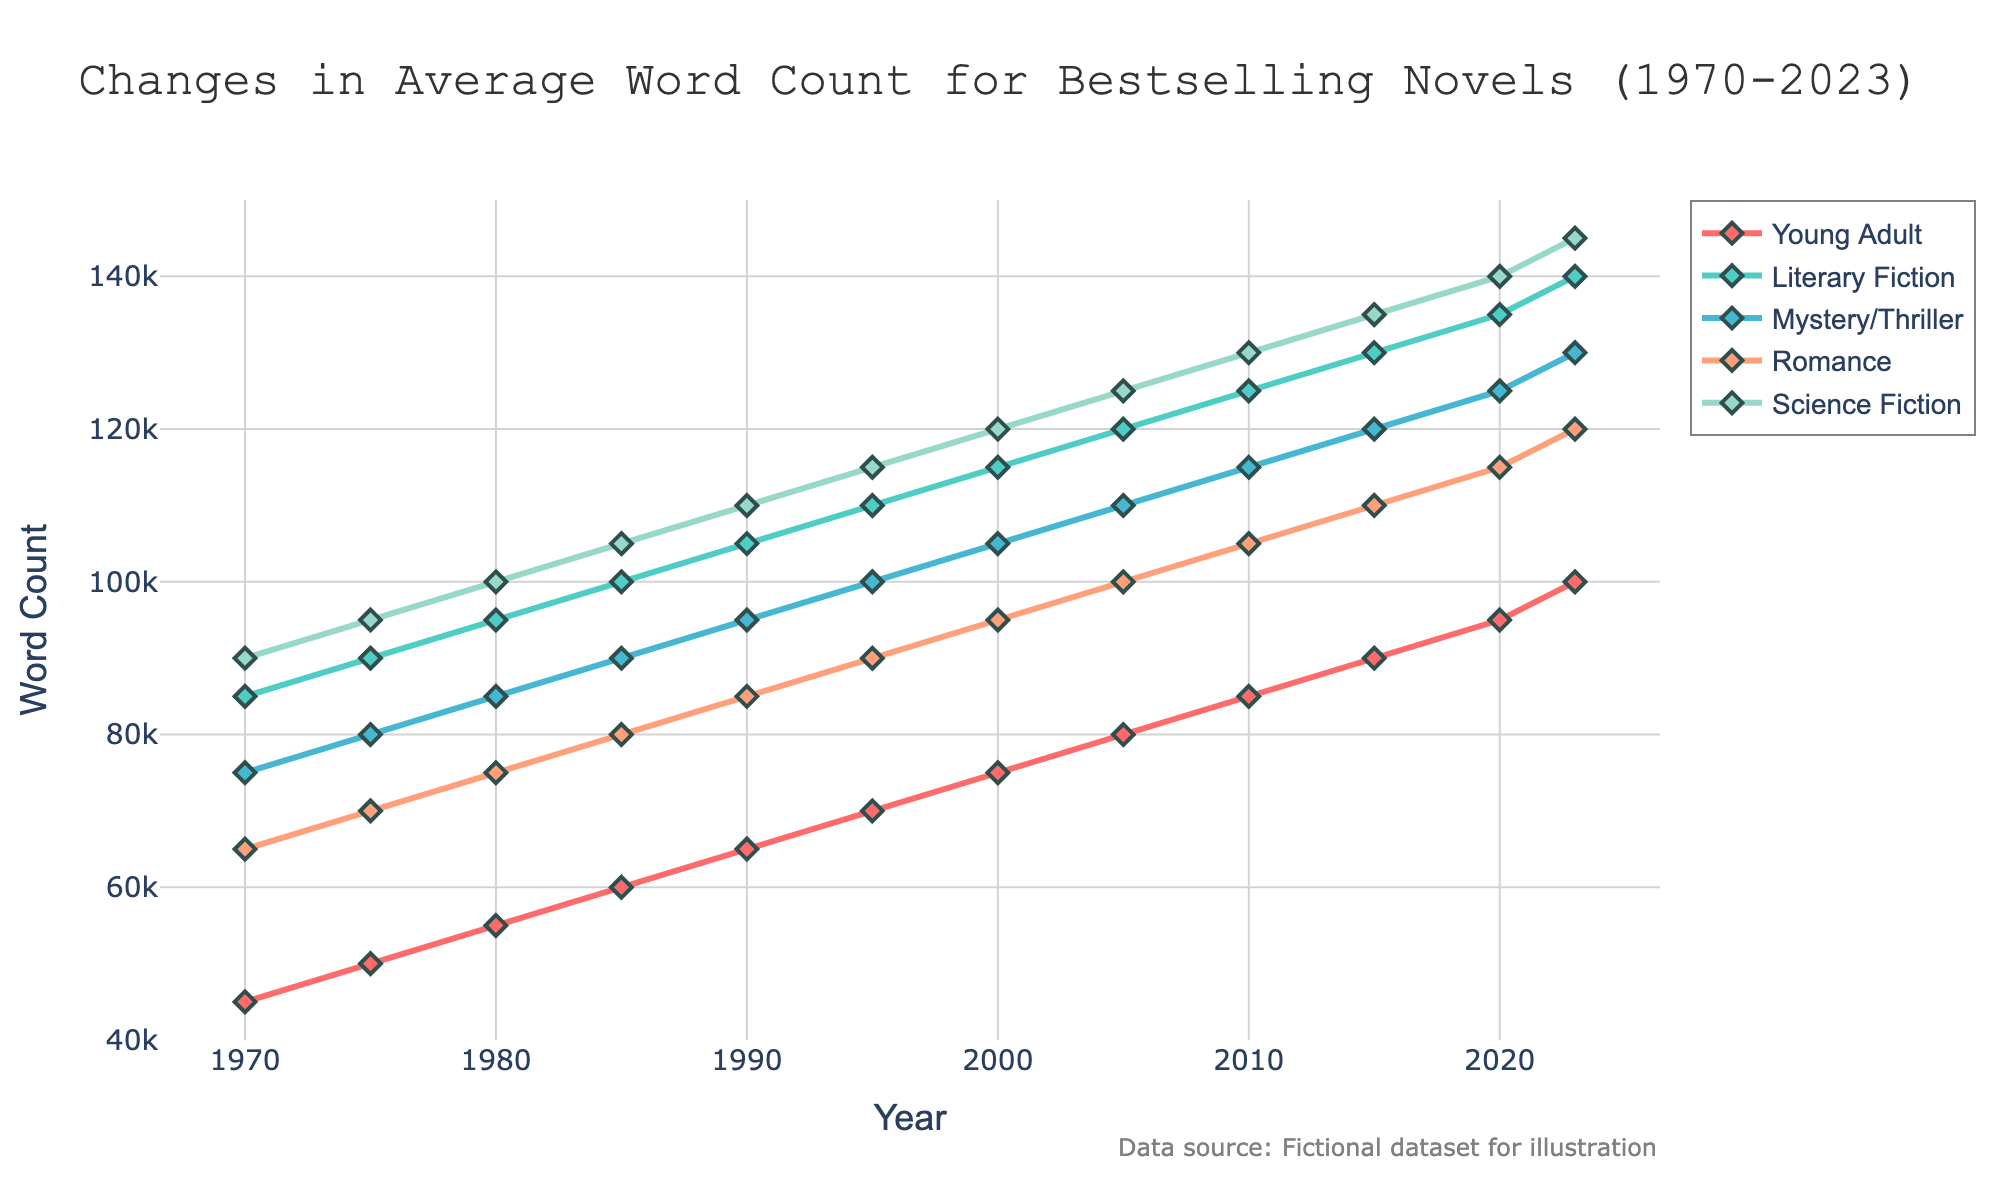What is the trend for the average word count of Young Adult novels from 1970 to 2023? The average word count for Young Adult novels consistently increases from 45,000 in 1970 to 100,000 in 2023. This upward trend is shown by the steadily rising line on the chart.
Answer: Consistently increasing Which genre has the highest average word count in 2023? In 2023, the Science Fiction genre has the highest average word count at 145,000 words, as indicated by the highest point on the graph at that year.
Answer: Science Fiction Which two genres show the greatest increase in average word count from 1970 to 2023? To find this, calculate the increase for each genre: 
- Young Adult: 100000 - 45000 = 55000 
- Literary Fiction: 140000 - 85000 = 55000 
- Mystery/Thriller: 130000 - 75000 = 55000 
- Romance: 120000 - 65000 = 55000 
- Science Fiction: 145000 - 90000 = 55000 
All genres show an equal increase of 55,000 words from 1970 to 2023.
Answer: All genres By how much did the average word count for Romance novels increase between 1980 and 2000? The average word count for Romance novels in 1980 is 75,000 words and in 2000 it is 95,000 words. To find the increase: 95000 - 75000 = 20000.
Answer: 20,000 words From which year did the average word count of Mystery/Thriller novels surpass 100,000? In the chart, Mystery/Thriller novels surpass 100,000 words in the year 2005. This is the first year where the y-value for Mystery/Thriller exceeds 100,000.
Answer: 2005 Between 1990 and 2010, which genre saw the smallest increase in average word count, and how much was the increase? Calculate the increase for each genre:
- Young Adult: 85000 - 65000 = 20000 
- Literary Fiction: 125000 - 105000 = 20000 
- Mystery/Thriller: 115000 - 95000 = 20000 
- Romance: 105000 - 85000 = 20000 
- Science Fiction: 130000 - 110000 = 20000 
All genres experienced an equal increase of 20,000 words from 1990 to 2010.
Answer: All genres, 20,000 words What are the color representations of the genres in the chart? The chart uses the following colors: 
- Young Adult: Red 
- Literary Fiction: Green 
- Mystery/Thriller: Blue 
- Romance: Light orange 
- Science Fiction: Light teal
Answer: Red, Green, Blue, Light orange, Light teal Was there any genre that saw a decline in average word count at any point from 1970 to 2023? By observing the lines for all genres on the chart, none of them show a decline at any point from 1970 to 2023. All lines consistently trend upwards.
Answer: No Comparing the average word counts in 1985, which genre had the lowest word count and what was it? In 1985, the average word counts are visually shown, and the Young Adult genre has the lowest word count at 60,000 words. This is the lowest point among the genres for that year.
Answer: Young Adult, 60,000 words Which genre showed the largest increase in average word count between 1975 and 1985? Calculate the increase for each genre:
- Young Adult: 60000 - 50000 = 10000 
- Literary Fiction: 100000 - 90000 = 10000
- Mystery/Thriller: 90000 - 80000 = 10000 
- Romance: 80000 - 70000 = 10000 
- Science Fiction: 105000 - 95000 = 10000 
All genres show an equal increase of 10,000 words between these years.
Answer: All genres, 10,000 words 